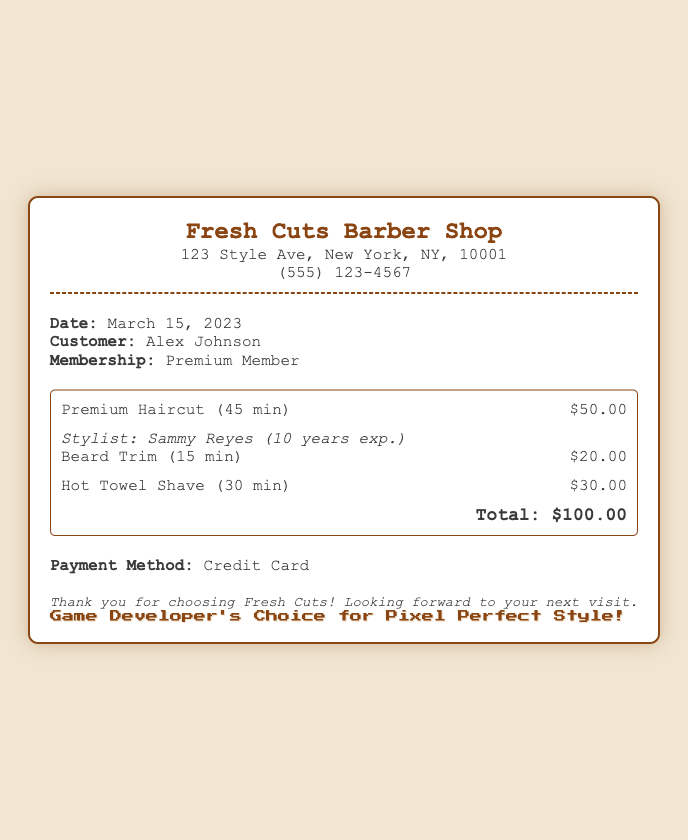What is the date of the service? The date of the service is clearly stated in the info section of the receipt.
Answer: March 15, 2023 Who was the stylist for the haircut? The stylist's name is mentioned along with their experience in the services section.
Answer: Sammy Reyes How many years of experience does the stylist have? The stylist's experience is explicitly mentioned in the services section of the receipt.
Answer: 10 years What is the total amount charged for the services? The total amount is presented at the bottom of the services section of the receipt.
Answer: $100.00 How much does a premium haircut cost? The cost of the premium haircut is listed in the services section.
Answer: $50.00 What additional grooming services were selected? This requires evaluating the list of services provided in the document.
Answer: Beard Trim, Hot Towel Shave What is the payment method used? The payment method is specified towards the end of the receipt.
Answer: Credit Card What is the customer's membership type? The membership type is provided in the info section of the document.
Answer: Premium Member 